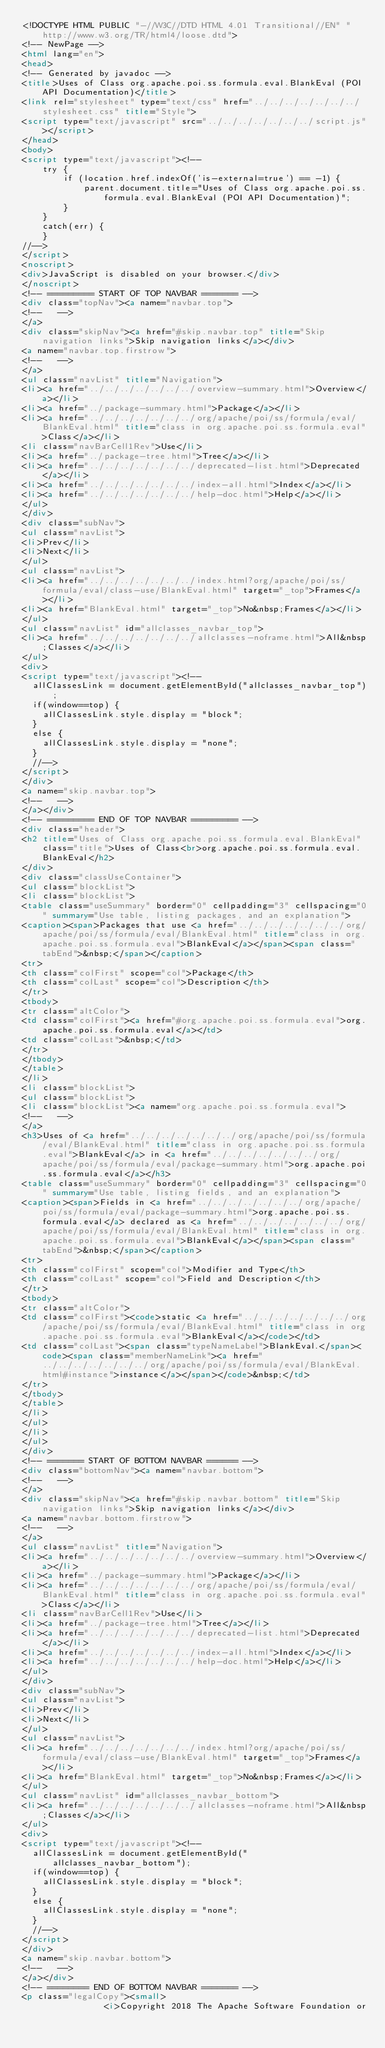<code> <loc_0><loc_0><loc_500><loc_500><_HTML_><!DOCTYPE HTML PUBLIC "-//W3C//DTD HTML 4.01 Transitional//EN" "http://www.w3.org/TR/html4/loose.dtd">
<!-- NewPage -->
<html lang="en">
<head>
<!-- Generated by javadoc -->
<title>Uses of Class org.apache.poi.ss.formula.eval.BlankEval (POI API Documentation)</title>
<link rel="stylesheet" type="text/css" href="../../../../../../../stylesheet.css" title="Style">
<script type="text/javascript" src="../../../../../../../script.js"></script>
</head>
<body>
<script type="text/javascript"><!--
    try {
        if (location.href.indexOf('is-external=true') == -1) {
            parent.document.title="Uses of Class org.apache.poi.ss.formula.eval.BlankEval (POI API Documentation)";
        }
    }
    catch(err) {
    }
//-->
</script>
<noscript>
<div>JavaScript is disabled on your browser.</div>
</noscript>
<!-- ========= START OF TOP NAVBAR ======= -->
<div class="topNav"><a name="navbar.top">
<!--   -->
</a>
<div class="skipNav"><a href="#skip.navbar.top" title="Skip navigation links">Skip navigation links</a></div>
<a name="navbar.top.firstrow">
<!--   -->
</a>
<ul class="navList" title="Navigation">
<li><a href="../../../../../../../overview-summary.html">Overview</a></li>
<li><a href="../package-summary.html">Package</a></li>
<li><a href="../../../../../../../org/apache/poi/ss/formula/eval/BlankEval.html" title="class in org.apache.poi.ss.formula.eval">Class</a></li>
<li class="navBarCell1Rev">Use</li>
<li><a href="../package-tree.html">Tree</a></li>
<li><a href="../../../../../../../deprecated-list.html">Deprecated</a></li>
<li><a href="../../../../../../../index-all.html">Index</a></li>
<li><a href="../../../../../../../help-doc.html">Help</a></li>
</ul>
</div>
<div class="subNav">
<ul class="navList">
<li>Prev</li>
<li>Next</li>
</ul>
<ul class="navList">
<li><a href="../../../../../../../index.html?org/apache/poi/ss/formula/eval/class-use/BlankEval.html" target="_top">Frames</a></li>
<li><a href="BlankEval.html" target="_top">No&nbsp;Frames</a></li>
</ul>
<ul class="navList" id="allclasses_navbar_top">
<li><a href="../../../../../../../allclasses-noframe.html">All&nbsp;Classes</a></li>
</ul>
<div>
<script type="text/javascript"><!--
  allClassesLink = document.getElementById("allclasses_navbar_top");
  if(window==top) {
    allClassesLink.style.display = "block";
  }
  else {
    allClassesLink.style.display = "none";
  }
  //-->
</script>
</div>
<a name="skip.navbar.top">
<!--   -->
</a></div>
<!-- ========= END OF TOP NAVBAR ========= -->
<div class="header">
<h2 title="Uses of Class org.apache.poi.ss.formula.eval.BlankEval" class="title">Uses of Class<br>org.apache.poi.ss.formula.eval.BlankEval</h2>
</div>
<div class="classUseContainer">
<ul class="blockList">
<li class="blockList">
<table class="useSummary" border="0" cellpadding="3" cellspacing="0" summary="Use table, listing packages, and an explanation">
<caption><span>Packages that use <a href="../../../../../../../org/apache/poi/ss/formula/eval/BlankEval.html" title="class in org.apache.poi.ss.formula.eval">BlankEval</a></span><span class="tabEnd">&nbsp;</span></caption>
<tr>
<th class="colFirst" scope="col">Package</th>
<th class="colLast" scope="col">Description</th>
</tr>
<tbody>
<tr class="altColor">
<td class="colFirst"><a href="#org.apache.poi.ss.formula.eval">org.apache.poi.ss.formula.eval</a></td>
<td class="colLast">&nbsp;</td>
</tr>
</tbody>
</table>
</li>
<li class="blockList">
<ul class="blockList">
<li class="blockList"><a name="org.apache.poi.ss.formula.eval">
<!--   -->
</a>
<h3>Uses of <a href="../../../../../../../org/apache/poi/ss/formula/eval/BlankEval.html" title="class in org.apache.poi.ss.formula.eval">BlankEval</a> in <a href="../../../../../../../org/apache/poi/ss/formula/eval/package-summary.html">org.apache.poi.ss.formula.eval</a></h3>
<table class="useSummary" border="0" cellpadding="3" cellspacing="0" summary="Use table, listing fields, and an explanation">
<caption><span>Fields in <a href="../../../../../../../org/apache/poi/ss/formula/eval/package-summary.html">org.apache.poi.ss.formula.eval</a> declared as <a href="../../../../../../../org/apache/poi/ss/formula/eval/BlankEval.html" title="class in org.apache.poi.ss.formula.eval">BlankEval</a></span><span class="tabEnd">&nbsp;</span></caption>
<tr>
<th class="colFirst" scope="col">Modifier and Type</th>
<th class="colLast" scope="col">Field and Description</th>
</tr>
<tbody>
<tr class="altColor">
<td class="colFirst"><code>static <a href="../../../../../../../org/apache/poi/ss/formula/eval/BlankEval.html" title="class in org.apache.poi.ss.formula.eval">BlankEval</a></code></td>
<td class="colLast"><span class="typeNameLabel">BlankEval.</span><code><span class="memberNameLink"><a href="../../../../../../../org/apache/poi/ss/formula/eval/BlankEval.html#instance">instance</a></span></code>&nbsp;</td>
</tr>
</tbody>
</table>
</li>
</ul>
</li>
</ul>
</div>
<!-- ======= START OF BOTTOM NAVBAR ====== -->
<div class="bottomNav"><a name="navbar.bottom">
<!--   -->
</a>
<div class="skipNav"><a href="#skip.navbar.bottom" title="Skip navigation links">Skip navigation links</a></div>
<a name="navbar.bottom.firstrow">
<!--   -->
</a>
<ul class="navList" title="Navigation">
<li><a href="../../../../../../../overview-summary.html">Overview</a></li>
<li><a href="../package-summary.html">Package</a></li>
<li><a href="../../../../../../../org/apache/poi/ss/formula/eval/BlankEval.html" title="class in org.apache.poi.ss.formula.eval">Class</a></li>
<li class="navBarCell1Rev">Use</li>
<li><a href="../package-tree.html">Tree</a></li>
<li><a href="../../../../../../../deprecated-list.html">Deprecated</a></li>
<li><a href="../../../../../../../index-all.html">Index</a></li>
<li><a href="../../../../../../../help-doc.html">Help</a></li>
</ul>
</div>
<div class="subNav">
<ul class="navList">
<li>Prev</li>
<li>Next</li>
</ul>
<ul class="navList">
<li><a href="../../../../../../../index.html?org/apache/poi/ss/formula/eval/class-use/BlankEval.html" target="_top">Frames</a></li>
<li><a href="BlankEval.html" target="_top">No&nbsp;Frames</a></li>
</ul>
<ul class="navList" id="allclasses_navbar_bottom">
<li><a href="../../../../../../../allclasses-noframe.html">All&nbsp;Classes</a></li>
</ul>
<div>
<script type="text/javascript"><!--
  allClassesLink = document.getElementById("allclasses_navbar_bottom");
  if(window==top) {
    allClassesLink.style.display = "block";
  }
  else {
    allClassesLink.style.display = "none";
  }
  //-->
</script>
</div>
<a name="skip.navbar.bottom">
<!--   -->
</a></div>
<!-- ======== END OF BOTTOM NAVBAR ======= -->
<p class="legalCopy"><small>
                <i>Copyright 2018 The Apache Software Foundation or</code> 